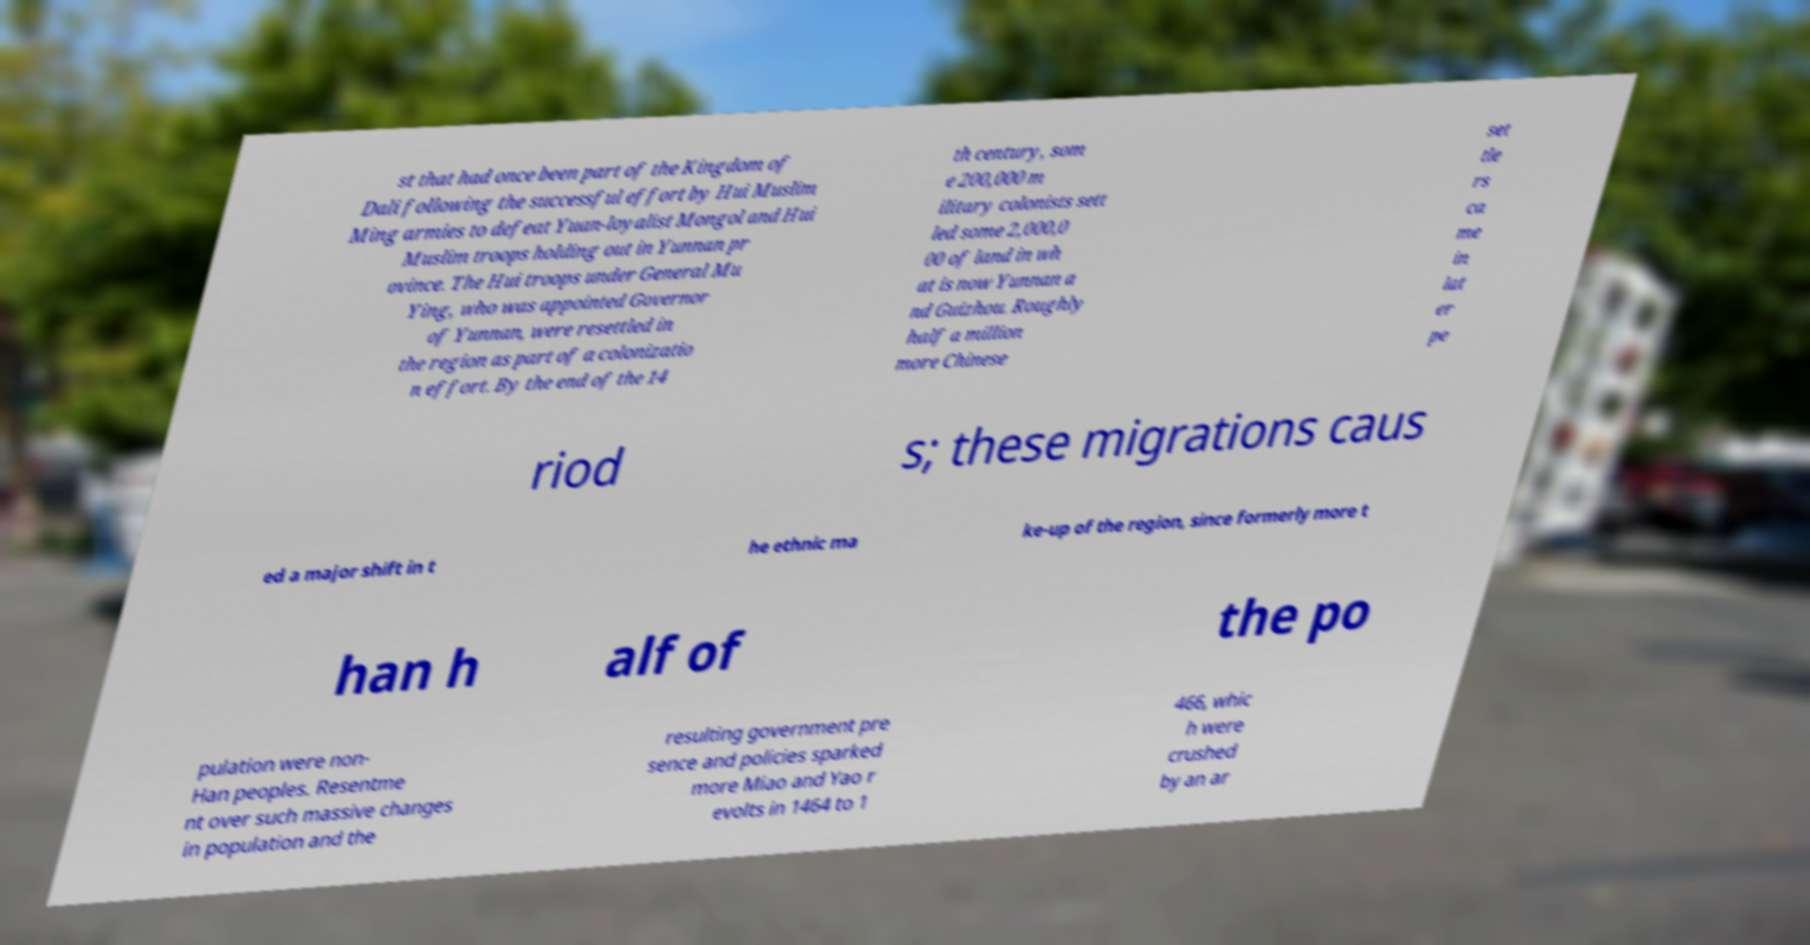For documentation purposes, I need the text within this image transcribed. Could you provide that? st that had once been part of the Kingdom of Dali following the successful effort by Hui Muslim Ming armies to defeat Yuan-loyalist Mongol and Hui Muslim troops holding out in Yunnan pr ovince. The Hui troops under General Mu Ying, who was appointed Governor of Yunnan, were resettled in the region as part of a colonizatio n effort. By the end of the 14 th century, som e 200,000 m ilitary colonists sett led some 2,000,0 00 of land in wh at is now Yunnan a nd Guizhou. Roughly half a million more Chinese set tle rs ca me in lat er pe riod s; these migrations caus ed a major shift in t he ethnic ma ke-up of the region, since formerly more t han h alf of the po pulation were non- Han peoples. Resentme nt over such massive changes in population and the resulting government pre sence and policies sparked more Miao and Yao r evolts in 1464 to 1 466, whic h were crushed by an ar 